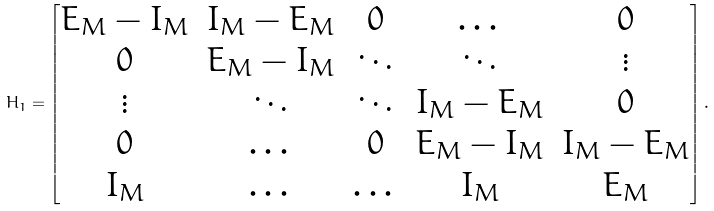<formula> <loc_0><loc_0><loc_500><loc_500>H _ { 1 } = \begin{bmatrix} E _ { M } - I _ { M } & I _ { M } - E _ { M } & 0 & \dots & 0 \\ 0 & E _ { M } - I _ { M } & \ddots & \ddots & \vdots \\ \vdots & \ddots & \ddots & I _ { M } - E _ { M } & 0 \\ 0 & \dots & 0 & E _ { M } - I _ { M } & I _ { M } - E _ { M } \\ I _ { M } & \dots & \dots & I _ { M } & E _ { M } \end{bmatrix} .</formula> 